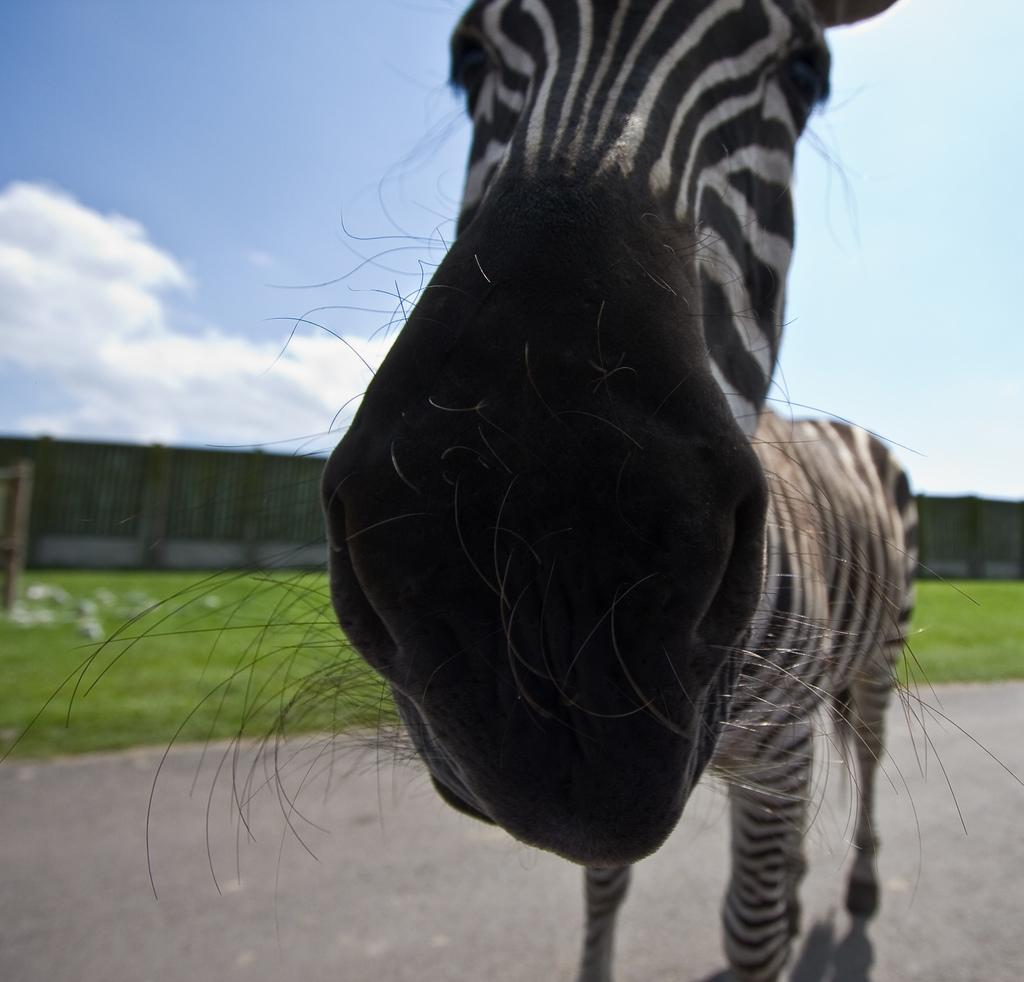What animal is in the center of the image? There is a zebra in the center of the image. Where is the zebra located? The zebra is on the road. What can be seen in the background of the image? There is grass, fencing, and the sky visible in the background of the image. What type of structure is in the background of the image? There is a wall in the background of the image. What type of watch is the zebra wearing in the image? The zebra is not wearing a watch in the image; it is a zebra, which is an animal and does not wear watches. 